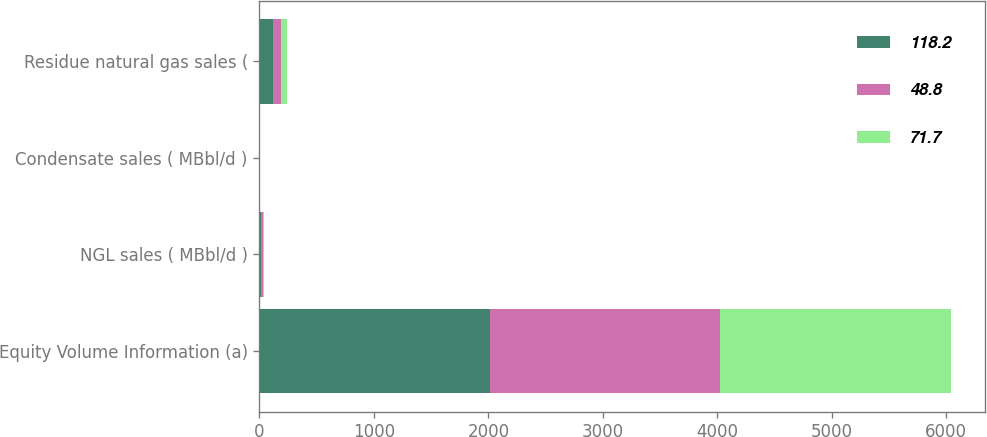<chart> <loc_0><loc_0><loc_500><loc_500><stacked_bar_chart><ecel><fcel>Equity Volume Information (a)<fcel>NGL sales ( MBbl/d )<fcel>Condensate sales ( MBbl/d )<fcel>Residue natural gas sales (<nl><fcel>118.2<fcel>2014<fcel>16.5<fcel>3.1<fcel>118.2<nl><fcel>48.8<fcel>2013<fcel>14.4<fcel>2.4<fcel>71.7<nl><fcel>71.7<fcel>2012<fcel>11.6<fcel>2.3<fcel>48.8<nl></chart> 